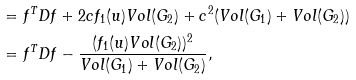<formula> <loc_0><loc_0><loc_500><loc_500>& = f ^ { T } D f + 2 c f _ { 1 } ( u ) V o l ( G _ { 2 } ) + c ^ { 2 } ( V o l ( G _ { 1 } ) + V o l ( G _ { 2 } ) ) \\ & = f ^ { T } D f - \frac { ( f _ { 1 } ( u ) V o l ( G _ { 2 } ) ) ^ { 2 } } { V o l ( G _ { 1 } ) + V o l ( G _ { 2 } ) } ,</formula> 